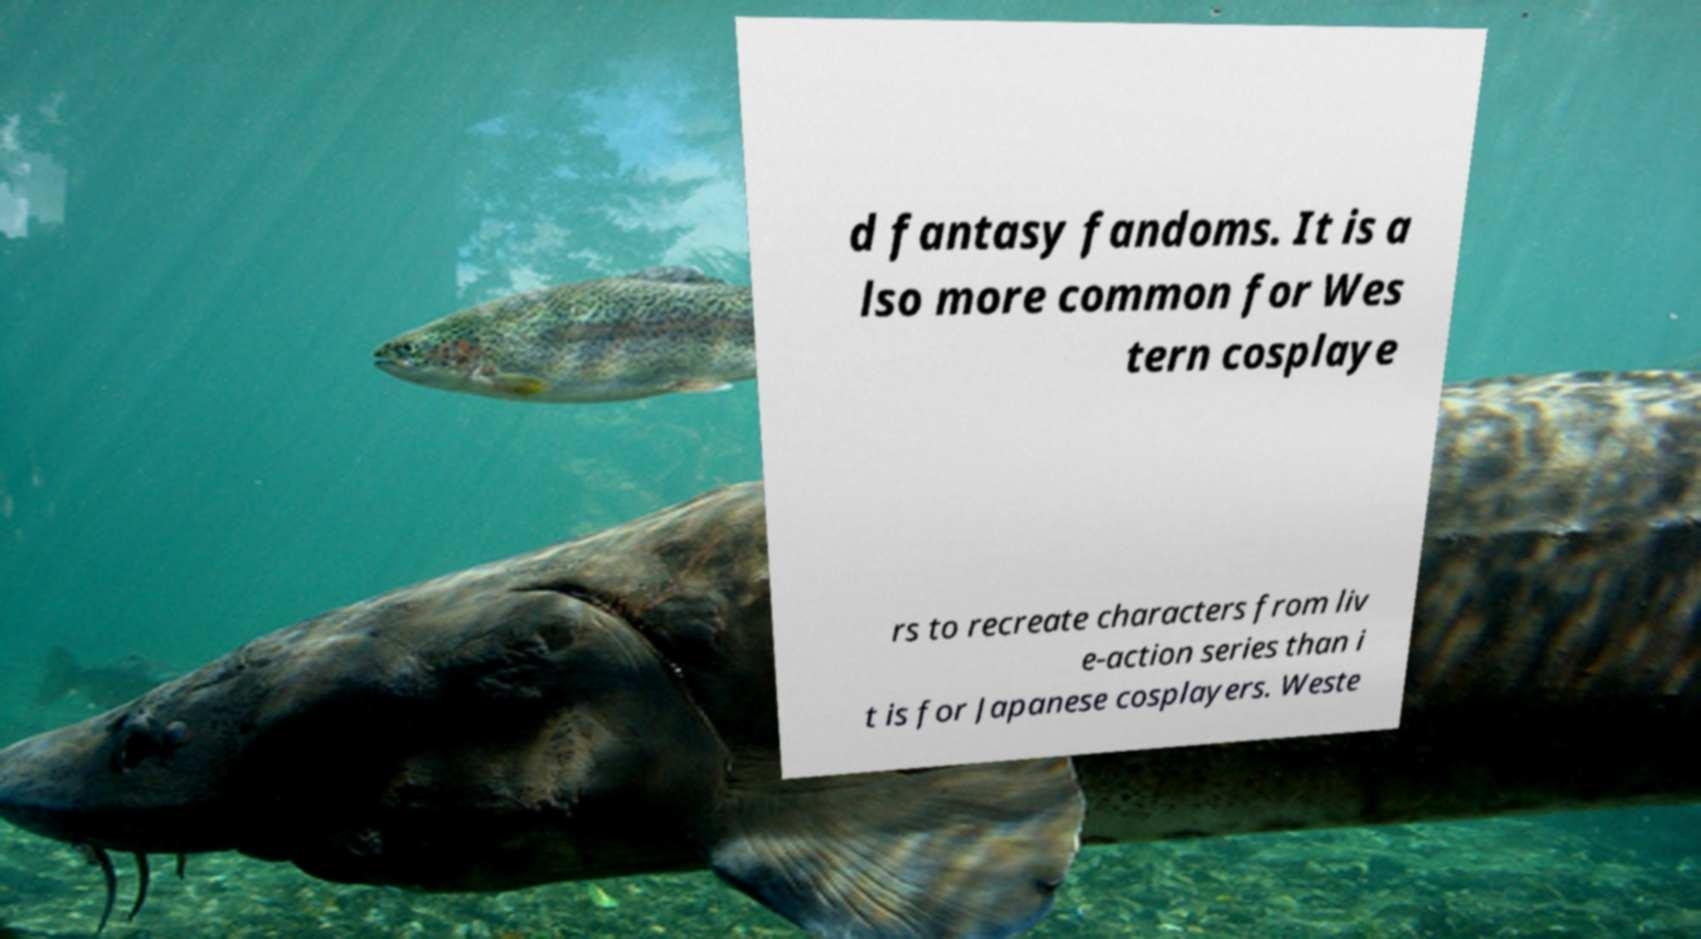For documentation purposes, I need the text within this image transcribed. Could you provide that? d fantasy fandoms. It is a lso more common for Wes tern cosplaye rs to recreate characters from liv e-action series than i t is for Japanese cosplayers. Weste 